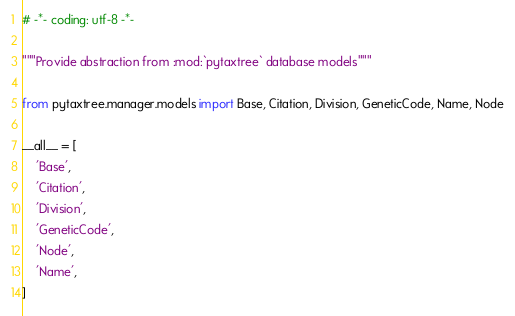Convert code to text. <code><loc_0><loc_0><loc_500><loc_500><_Python_># -*- coding: utf-8 -*-

"""Provide abstraction from :mod:`pytaxtree` database models"""

from pytaxtree.manager.models import Base, Citation, Division, GeneticCode, Name, Node

__all__ = [
    'Base',
    'Citation',
    'Division',
    'GeneticCode',
    'Node',
    'Name',
]
</code> 